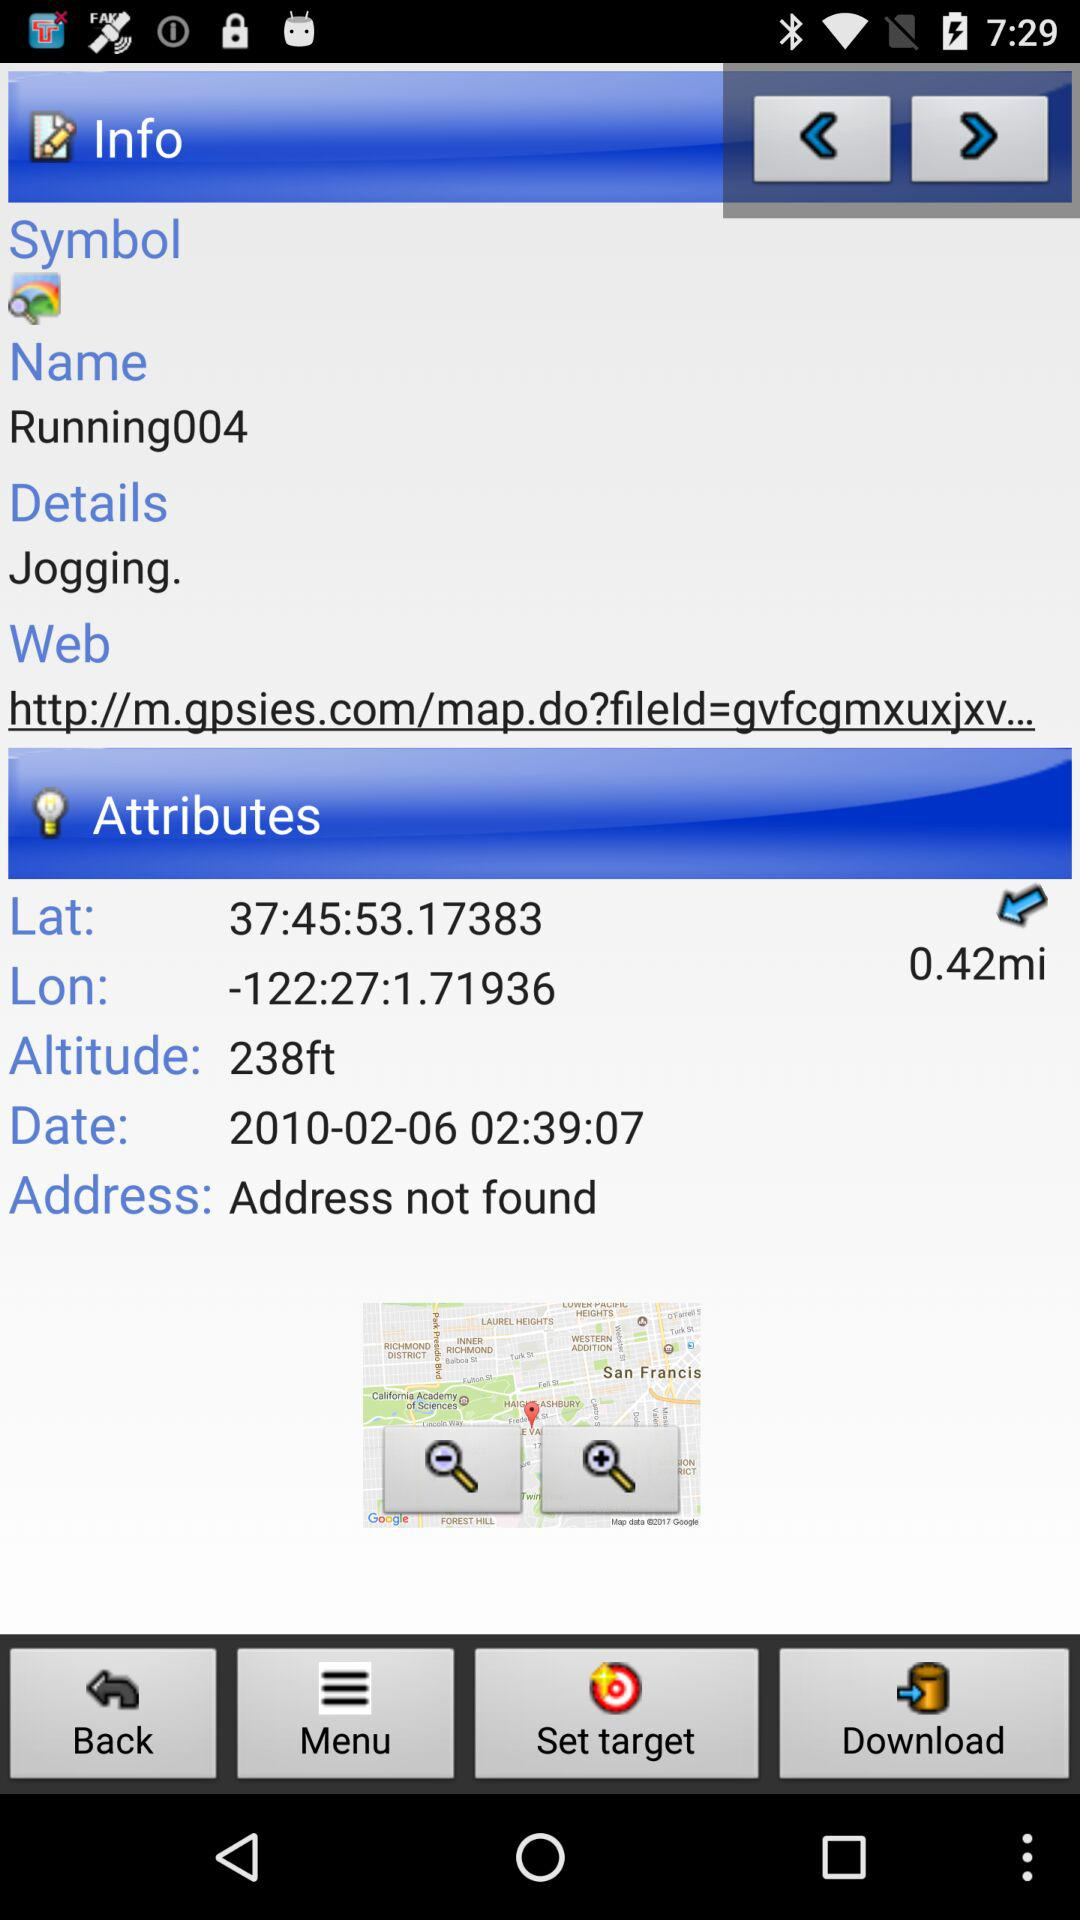What's the mentioned date? The mentioned date is February 6, 2010. 